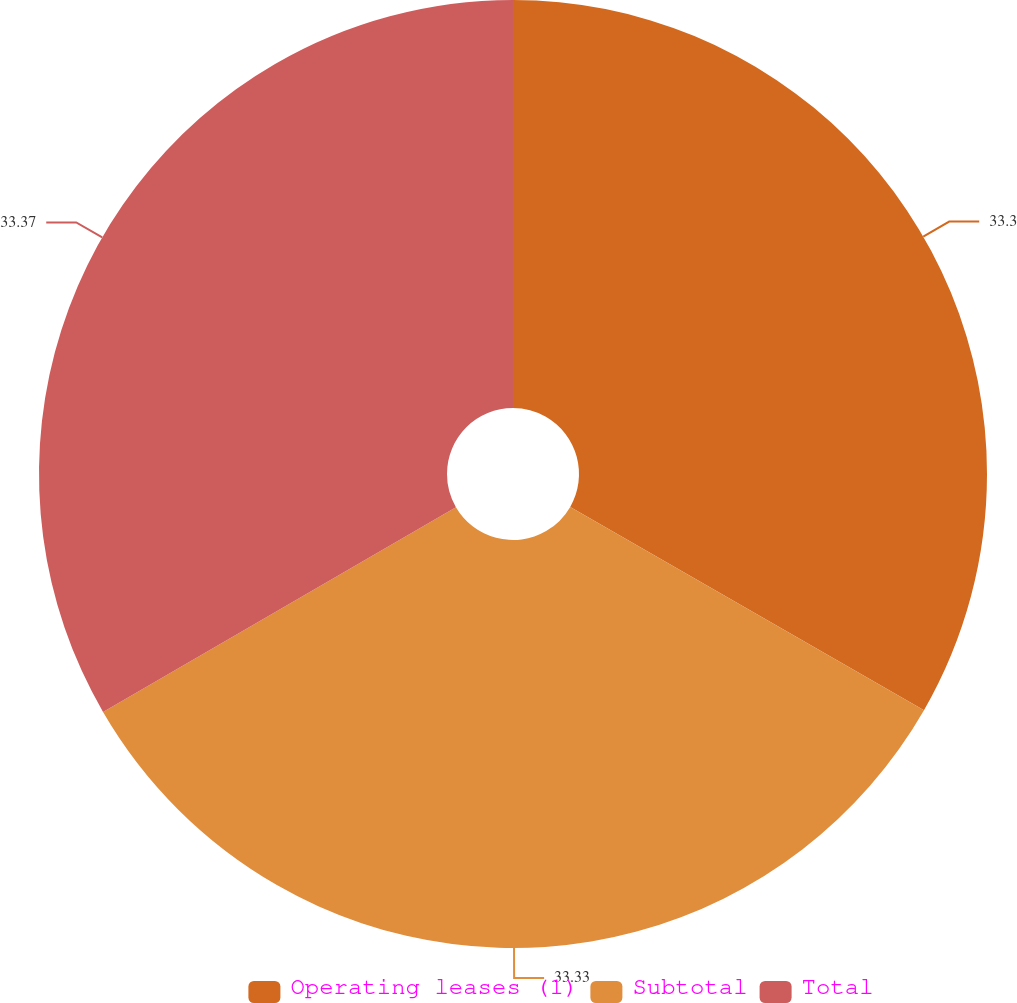<chart> <loc_0><loc_0><loc_500><loc_500><pie_chart><fcel>Operating leases (1)<fcel>Subtotal<fcel>Total<nl><fcel>33.3%<fcel>33.33%<fcel>33.37%<nl></chart> 